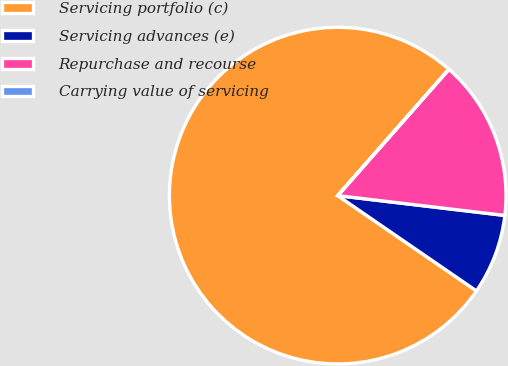<chart> <loc_0><loc_0><loc_500><loc_500><pie_chart><fcel>Servicing portfolio (c)<fcel>Servicing advances (e)<fcel>Repurchase and recourse<fcel>Carrying value of servicing<nl><fcel>76.89%<fcel>7.7%<fcel>15.39%<fcel>0.01%<nl></chart> 